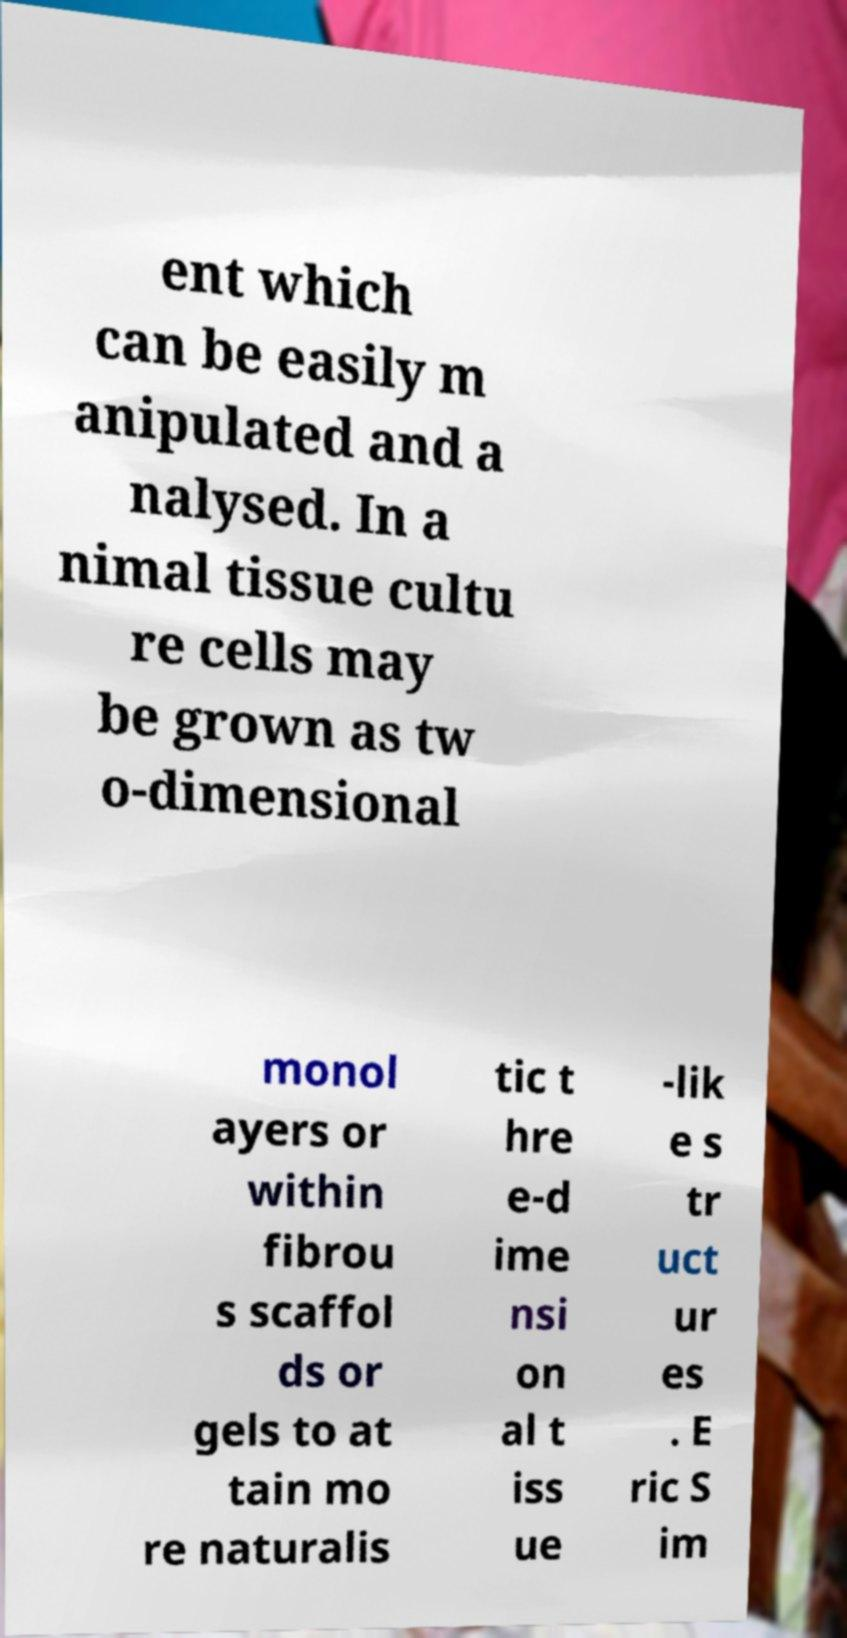Can you read and provide the text displayed in the image?This photo seems to have some interesting text. Can you extract and type it out for me? ent which can be easily m anipulated and a nalysed. In a nimal tissue cultu re cells may be grown as tw o-dimensional monol ayers or within fibrou s scaffol ds or gels to at tain mo re naturalis tic t hre e-d ime nsi on al t iss ue -lik e s tr uct ur es . E ric S im 